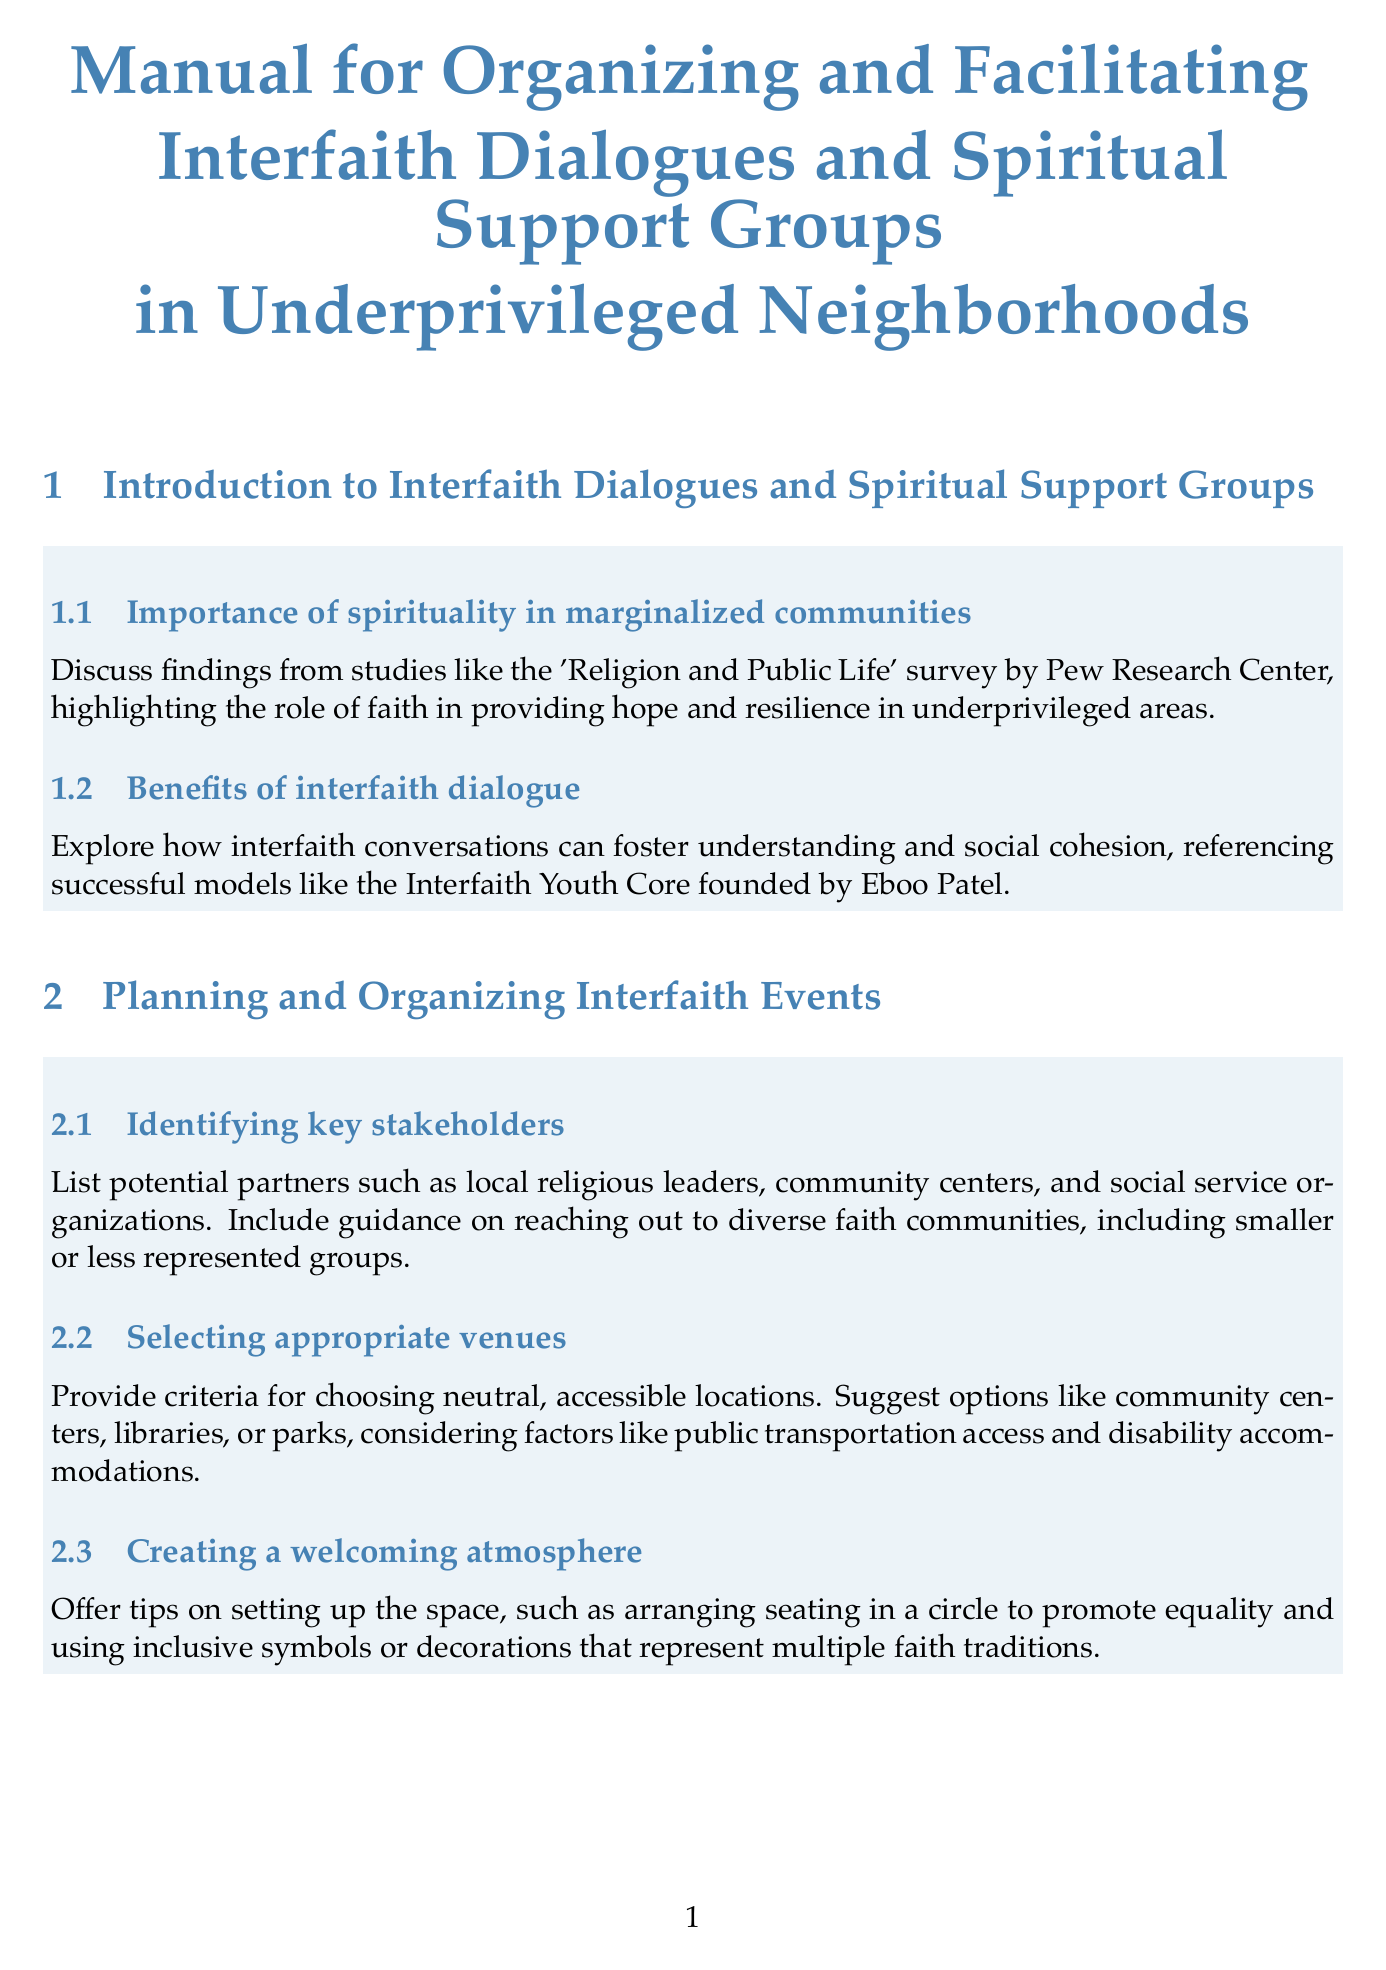What is the first section of the manual? The first section is titled "Introduction to Interfaith Dialogues and Spiritual Support Groups."
Answer: Introduction to Interfaith Dialogues and Spiritual Support Groups Which model is referenced for fostering understanding in interfaith dialogue? The manual references the Interfaith Youth Core founded by Eboo Patel as a successful model.
Answer: Interfaith Youth Core What is one suggested venue type for interfaith events? The document lists community centers as a suggested venue.
Answer: Community centers What is the goal of active listening techniques mentioned in the manual? The goal is to enhance communication and understanding during dialogues.
Answer: Enhance communication and understanding Which framework does the document suggest for addressing conflicts? The document references the Thomas-Kilmann Conflict Mode Instrument for conflict resolution.
Answer: Thomas-Kilmann Conflict Mode Instrument What does the manual suggest for accommodating dietary restrictions at events? It provides guidance on offering inclusive food options considering religious dietary laws.
Answer: Offering inclusive food options What is the purpose of peer facilitator training in spiritual support groups? It prepares community members to lead support groups.
Answer: Prepare community members to lead support groups How should feedback mechanisms be designed according to the manual? The manual suggests using anonymous surveys or focus groups for gathering feedback.
Answer: Anonymous surveys or focus groups What is one approach to address language barriers in interfaith events? The manual suggests partnering with local translation services.
Answer: Partnering with local translation services 